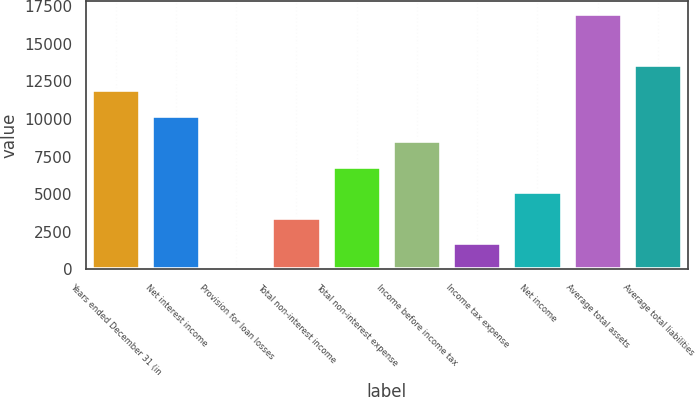<chart> <loc_0><loc_0><loc_500><loc_500><bar_chart><fcel>Years ended December 31 (in<fcel>Net interest income<fcel>Provision for loan losses<fcel>Total non-interest income<fcel>Total non-interest expense<fcel>Income before income tax<fcel>Income tax expense<fcel>Net income<fcel>Average total assets<fcel>Average total liabilities<nl><fcel>11899.8<fcel>10206.6<fcel>47.3<fcel>3433.74<fcel>6820.18<fcel>8513.4<fcel>1740.52<fcel>5126.96<fcel>16979.5<fcel>13593.1<nl></chart> 